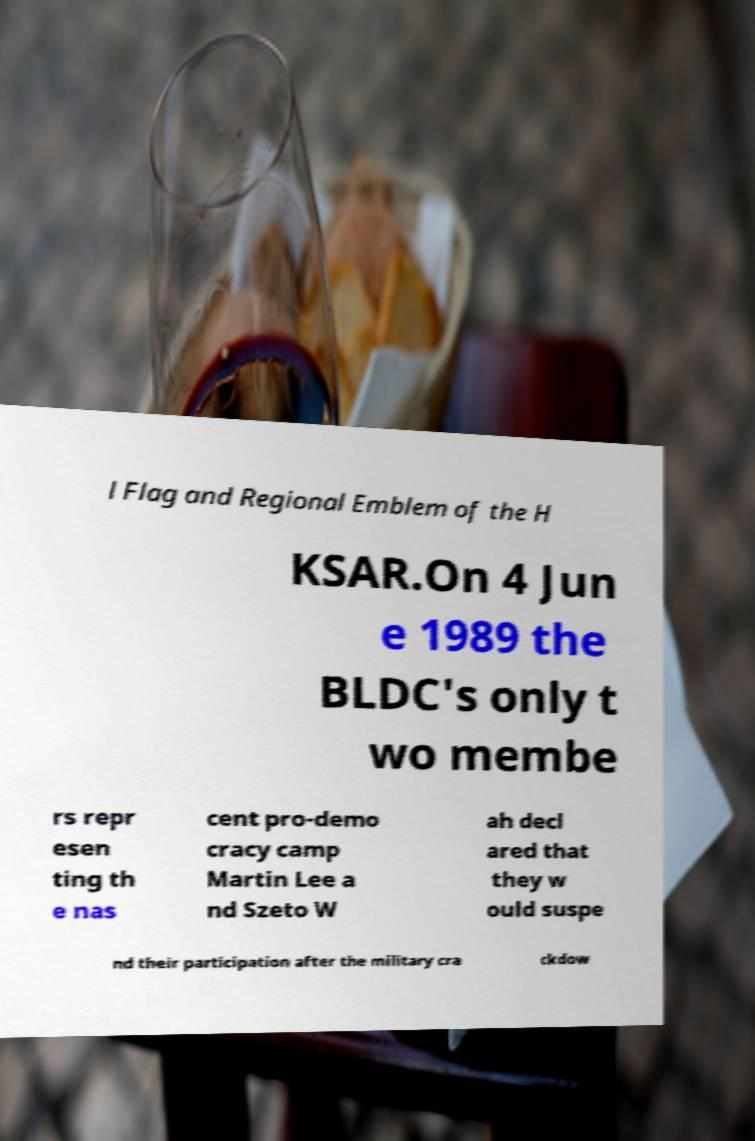Could you assist in decoding the text presented in this image and type it out clearly? l Flag and Regional Emblem of the H KSAR.On 4 Jun e 1989 the BLDC's only t wo membe rs repr esen ting th e nas cent pro-demo cracy camp Martin Lee a nd Szeto W ah decl ared that they w ould suspe nd their participation after the military cra ckdow 